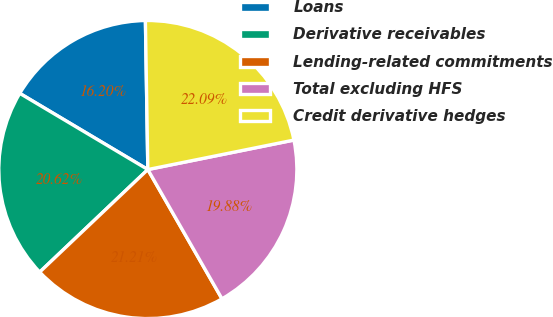Convert chart. <chart><loc_0><loc_0><loc_500><loc_500><pie_chart><fcel>Loans<fcel>Derivative receivables<fcel>Lending-related commitments<fcel>Total excluding HFS<fcel>Credit derivative hedges<nl><fcel>16.2%<fcel>20.62%<fcel>21.21%<fcel>19.88%<fcel>22.09%<nl></chart> 